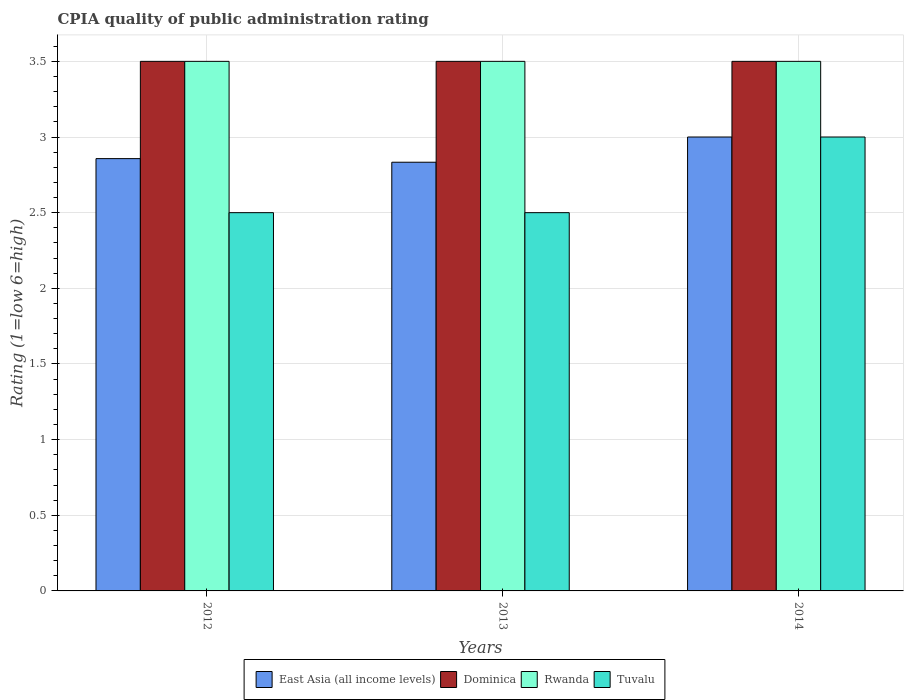How many different coloured bars are there?
Ensure brevity in your answer.  4. What is the label of the 1st group of bars from the left?
Keep it short and to the point. 2012. What is the CPIA rating in East Asia (all income levels) in 2014?
Offer a very short reply. 3. Across all years, what is the maximum CPIA rating in Dominica?
Ensure brevity in your answer.  3.5. In which year was the CPIA rating in Dominica maximum?
Your response must be concise. 2012. What is the average CPIA rating in East Asia (all income levels) per year?
Keep it short and to the point. 2.9. In the year 2012, what is the difference between the CPIA rating in Dominica and CPIA rating in East Asia (all income levels)?
Give a very brief answer. 0.64. In how many years, is the CPIA rating in Dominica greater than 3?
Give a very brief answer. 3. What is the ratio of the CPIA rating in East Asia (all income levels) in 2013 to that in 2014?
Give a very brief answer. 0.94. Is the CPIA rating in Dominica in 2012 less than that in 2013?
Offer a very short reply. No. What is the difference between the highest and the second highest CPIA rating in Dominica?
Your response must be concise. 0. Is the sum of the CPIA rating in Dominica in 2012 and 2013 greater than the maximum CPIA rating in Tuvalu across all years?
Your answer should be very brief. Yes. What does the 3rd bar from the left in 2014 represents?
Offer a very short reply. Rwanda. What does the 2nd bar from the right in 2014 represents?
Keep it short and to the point. Rwanda. Are the values on the major ticks of Y-axis written in scientific E-notation?
Offer a very short reply. No. Does the graph contain grids?
Your answer should be compact. Yes. How many legend labels are there?
Your answer should be very brief. 4. What is the title of the graph?
Ensure brevity in your answer.  CPIA quality of public administration rating. Does "Luxembourg" appear as one of the legend labels in the graph?
Ensure brevity in your answer.  No. What is the label or title of the X-axis?
Provide a short and direct response. Years. What is the label or title of the Y-axis?
Make the answer very short. Rating (1=low 6=high). What is the Rating (1=low 6=high) in East Asia (all income levels) in 2012?
Your answer should be compact. 2.86. What is the Rating (1=low 6=high) in Rwanda in 2012?
Offer a very short reply. 3.5. What is the Rating (1=low 6=high) in East Asia (all income levels) in 2013?
Keep it short and to the point. 2.83. What is the Rating (1=low 6=high) of Rwanda in 2013?
Provide a short and direct response. 3.5. What is the Rating (1=low 6=high) of East Asia (all income levels) in 2014?
Offer a terse response. 3. What is the Rating (1=low 6=high) of Dominica in 2014?
Make the answer very short. 3.5. Across all years, what is the maximum Rating (1=low 6=high) of Dominica?
Provide a short and direct response. 3.5. Across all years, what is the maximum Rating (1=low 6=high) of Rwanda?
Provide a short and direct response. 3.5. Across all years, what is the maximum Rating (1=low 6=high) of Tuvalu?
Your response must be concise. 3. Across all years, what is the minimum Rating (1=low 6=high) in East Asia (all income levels)?
Your answer should be very brief. 2.83. What is the total Rating (1=low 6=high) in East Asia (all income levels) in the graph?
Keep it short and to the point. 8.69. What is the total Rating (1=low 6=high) in Dominica in the graph?
Make the answer very short. 10.5. What is the total Rating (1=low 6=high) of Tuvalu in the graph?
Ensure brevity in your answer.  8. What is the difference between the Rating (1=low 6=high) of East Asia (all income levels) in 2012 and that in 2013?
Ensure brevity in your answer.  0.02. What is the difference between the Rating (1=low 6=high) in Dominica in 2012 and that in 2013?
Your answer should be very brief. 0. What is the difference between the Rating (1=low 6=high) of East Asia (all income levels) in 2012 and that in 2014?
Offer a terse response. -0.14. What is the difference between the Rating (1=low 6=high) in Dominica in 2012 and that in 2014?
Offer a very short reply. 0. What is the difference between the Rating (1=low 6=high) in Rwanda in 2012 and that in 2014?
Make the answer very short. 0. What is the difference between the Rating (1=low 6=high) of Tuvalu in 2012 and that in 2014?
Provide a succinct answer. -0.5. What is the difference between the Rating (1=low 6=high) in Dominica in 2013 and that in 2014?
Make the answer very short. 0. What is the difference between the Rating (1=low 6=high) of Tuvalu in 2013 and that in 2014?
Keep it short and to the point. -0.5. What is the difference between the Rating (1=low 6=high) of East Asia (all income levels) in 2012 and the Rating (1=low 6=high) of Dominica in 2013?
Your answer should be very brief. -0.64. What is the difference between the Rating (1=low 6=high) in East Asia (all income levels) in 2012 and the Rating (1=low 6=high) in Rwanda in 2013?
Your answer should be compact. -0.64. What is the difference between the Rating (1=low 6=high) of East Asia (all income levels) in 2012 and the Rating (1=low 6=high) of Tuvalu in 2013?
Give a very brief answer. 0.36. What is the difference between the Rating (1=low 6=high) in Dominica in 2012 and the Rating (1=low 6=high) in Tuvalu in 2013?
Offer a terse response. 1. What is the difference between the Rating (1=low 6=high) in East Asia (all income levels) in 2012 and the Rating (1=low 6=high) in Dominica in 2014?
Your response must be concise. -0.64. What is the difference between the Rating (1=low 6=high) of East Asia (all income levels) in 2012 and the Rating (1=low 6=high) of Rwanda in 2014?
Provide a short and direct response. -0.64. What is the difference between the Rating (1=low 6=high) in East Asia (all income levels) in 2012 and the Rating (1=low 6=high) in Tuvalu in 2014?
Make the answer very short. -0.14. What is the difference between the Rating (1=low 6=high) in Dominica in 2012 and the Rating (1=low 6=high) in Tuvalu in 2014?
Keep it short and to the point. 0.5. What is the difference between the Rating (1=low 6=high) of East Asia (all income levels) in 2013 and the Rating (1=low 6=high) of Dominica in 2014?
Keep it short and to the point. -0.67. What is the difference between the Rating (1=low 6=high) of East Asia (all income levels) in 2013 and the Rating (1=low 6=high) of Tuvalu in 2014?
Your answer should be compact. -0.17. What is the difference between the Rating (1=low 6=high) in Dominica in 2013 and the Rating (1=low 6=high) in Rwanda in 2014?
Ensure brevity in your answer.  0. What is the difference between the Rating (1=low 6=high) in Rwanda in 2013 and the Rating (1=low 6=high) in Tuvalu in 2014?
Your answer should be compact. 0.5. What is the average Rating (1=low 6=high) of East Asia (all income levels) per year?
Make the answer very short. 2.9. What is the average Rating (1=low 6=high) in Rwanda per year?
Your response must be concise. 3.5. What is the average Rating (1=low 6=high) in Tuvalu per year?
Give a very brief answer. 2.67. In the year 2012, what is the difference between the Rating (1=low 6=high) of East Asia (all income levels) and Rating (1=low 6=high) of Dominica?
Keep it short and to the point. -0.64. In the year 2012, what is the difference between the Rating (1=low 6=high) of East Asia (all income levels) and Rating (1=low 6=high) of Rwanda?
Give a very brief answer. -0.64. In the year 2012, what is the difference between the Rating (1=low 6=high) in East Asia (all income levels) and Rating (1=low 6=high) in Tuvalu?
Ensure brevity in your answer.  0.36. In the year 2013, what is the difference between the Rating (1=low 6=high) of East Asia (all income levels) and Rating (1=low 6=high) of Dominica?
Ensure brevity in your answer.  -0.67. In the year 2013, what is the difference between the Rating (1=low 6=high) of East Asia (all income levels) and Rating (1=low 6=high) of Tuvalu?
Make the answer very short. 0.33. In the year 2013, what is the difference between the Rating (1=low 6=high) of Dominica and Rating (1=low 6=high) of Tuvalu?
Your response must be concise. 1. In the year 2013, what is the difference between the Rating (1=low 6=high) in Rwanda and Rating (1=low 6=high) in Tuvalu?
Offer a very short reply. 1. In the year 2014, what is the difference between the Rating (1=low 6=high) in East Asia (all income levels) and Rating (1=low 6=high) in Dominica?
Provide a short and direct response. -0.5. In the year 2014, what is the difference between the Rating (1=low 6=high) of Rwanda and Rating (1=low 6=high) of Tuvalu?
Provide a short and direct response. 0.5. What is the ratio of the Rating (1=low 6=high) in East Asia (all income levels) in 2012 to that in 2013?
Provide a succinct answer. 1.01. What is the ratio of the Rating (1=low 6=high) in Rwanda in 2012 to that in 2013?
Give a very brief answer. 1. What is the ratio of the Rating (1=low 6=high) of Tuvalu in 2012 to that in 2013?
Provide a short and direct response. 1. What is the ratio of the Rating (1=low 6=high) in Dominica in 2012 to that in 2014?
Give a very brief answer. 1. What is the ratio of the Rating (1=low 6=high) in Rwanda in 2012 to that in 2014?
Offer a very short reply. 1. What is the ratio of the Rating (1=low 6=high) in Rwanda in 2013 to that in 2014?
Ensure brevity in your answer.  1. What is the ratio of the Rating (1=low 6=high) of Tuvalu in 2013 to that in 2014?
Your answer should be compact. 0.83. What is the difference between the highest and the second highest Rating (1=low 6=high) in East Asia (all income levels)?
Ensure brevity in your answer.  0.14. What is the difference between the highest and the second highest Rating (1=low 6=high) in Dominica?
Provide a short and direct response. 0. What is the difference between the highest and the second highest Rating (1=low 6=high) in Rwanda?
Ensure brevity in your answer.  0. What is the difference between the highest and the lowest Rating (1=low 6=high) of East Asia (all income levels)?
Offer a terse response. 0.17. What is the difference between the highest and the lowest Rating (1=low 6=high) of Rwanda?
Provide a short and direct response. 0. What is the difference between the highest and the lowest Rating (1=low 6=high) in Tuvalu?
Ensure brevity in your answer.  0.5. 